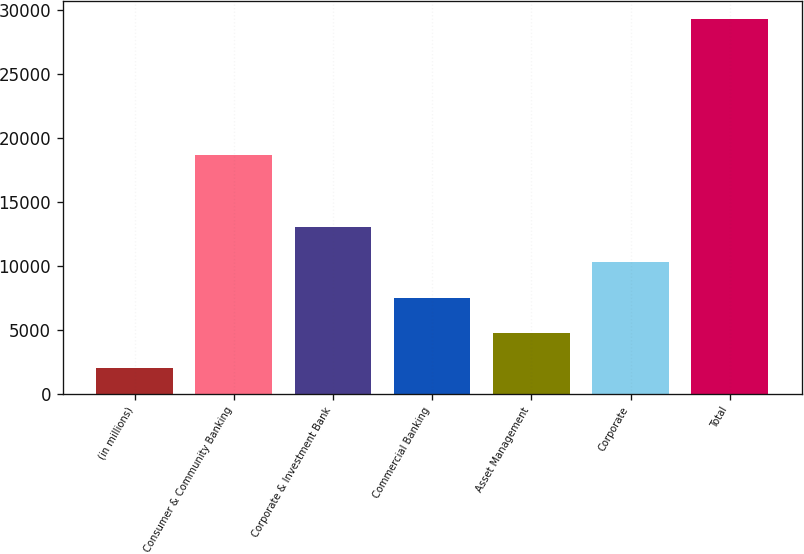Convert chart. <chart><loc_0><loc_0><loc_500><loc_500><bar_chart><fcel>(in millions)<fcel>Consumer & Community Banking<fcel>Corporate & Investment Bank<fcel>Commercial Banking<fcel>Asset Management<fcel>Corporate<fcel>Total<nl><fcel>2013<fcel>18695<fcel>13001.4<fcel>7461.8<fcel>4737.4<fcel>10277<fcel>29257<nl></chart> 